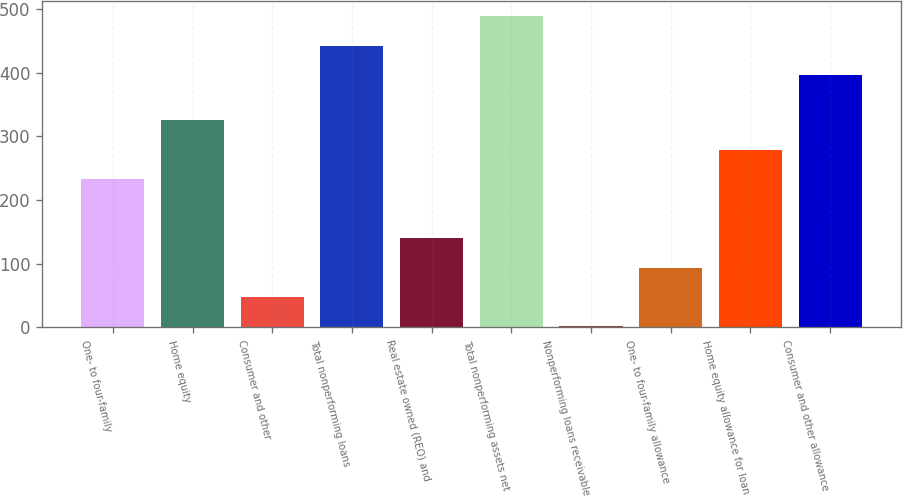Convert chart. <chart><loc_0><loc_0><loc_500><loc_500><bar_chart><fcel>One- to four-family<fcel>Home equity<fcel>Consumer and other<fcel>Total nonperforming loans<fcel>Real estate owned (REO) and<fcel>Total nonperforming assets net<fcel>Nonperforming loans receivable<fcel>One- to four-family allowance<fcel>Home equity allowance for loan<fcel>Consumer and other allowance<nl><fcel>232.82<fcel>325.4<fcel>47.66<fcel>443<fcel>140.24<fcel>489.29<fcel>1.37<fcel>93.95<fcel>279.11<fcel>396.71<nl></chart> 